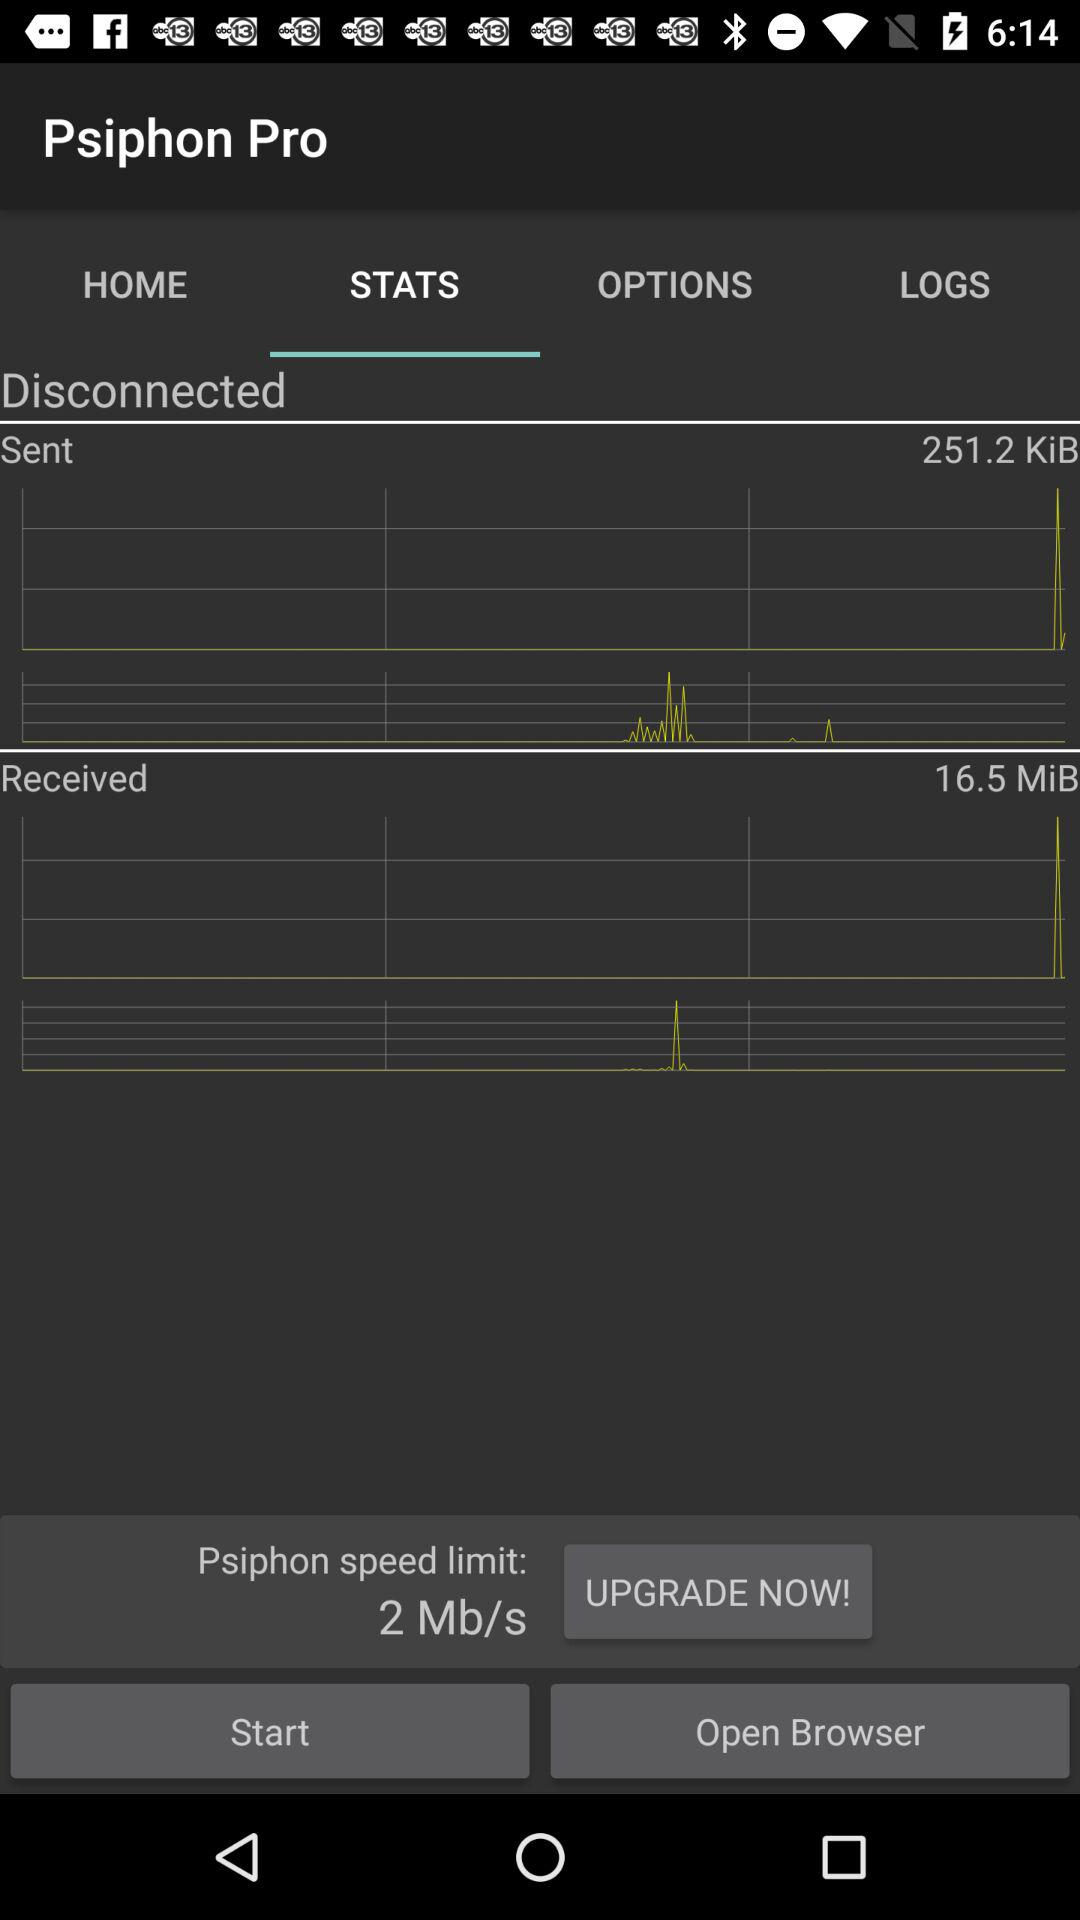Which tab has been selected? The selected tab is "STATS". 